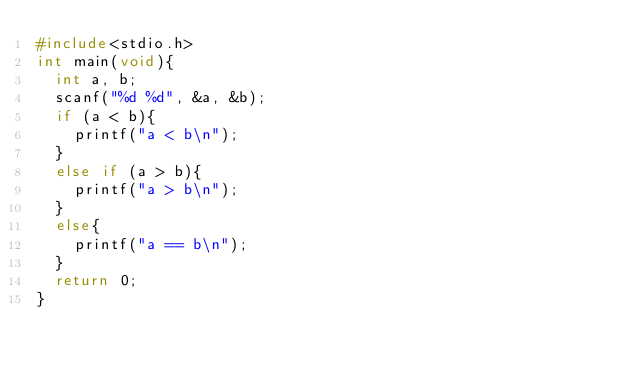Convert code to text. <code><loc_0><loc_0><loc_500><loc_500><_C_>#include<stdio.h>
int main(void){
	int a, b;
	scanf("%d %d", &a, &b);
	if (a < b){
		printf("a < b\n");
	}
	else if (a > b){
		printf("a > b\n");
	}
	else{
		printf("a == b\n");
	}
	return 0;
}</code> 